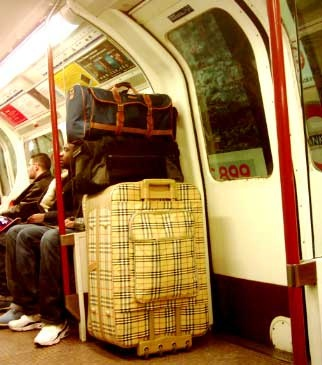Describe the objects in this image and their specific colors. I can see suitcase in tan, olive, khaki, and orange tones, people in tan, black, and maroon tones, handbag in tan, black, maroon, and olive tones, bench in tan, black, and maroon tones, and people in tan, black, maroon, and brown tones in this image. 